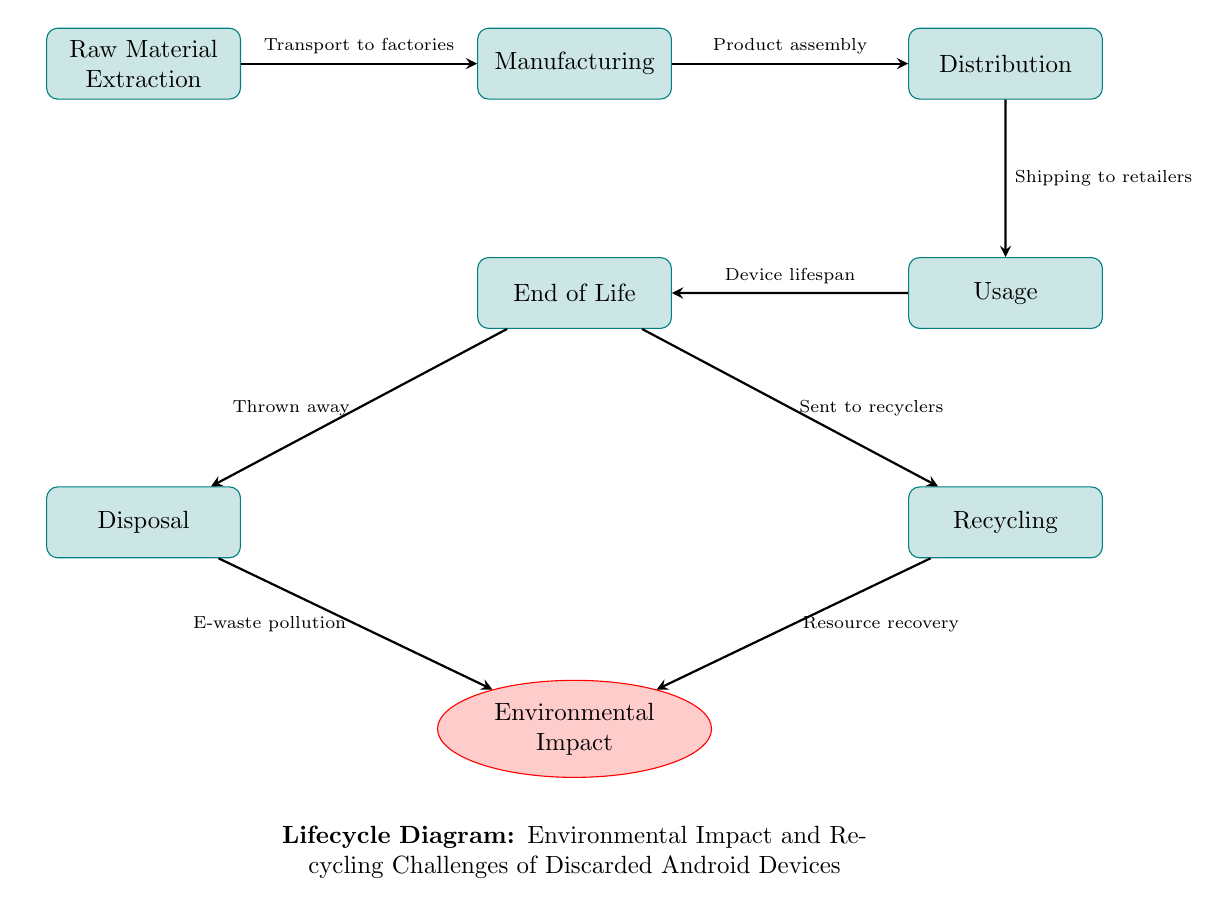What is the first step in the lifecycle of discarded Android devices? The first step in the lifecycle diagram is "Raw Material Extraction." It is the starting point before manufacturing.
Answer: Raw Material Extraction How many processes are depicted in the diagram? The diagram includes six processes: Raw Material Extraction, Manufacturing, Distribution, Usage, End of Life, Disposal, and Recycling. Counting these gives a total of six.
Answer: Six What happens during the 'End of Life' stage? During the 'End of Life' stage, devices can either be "Thrown away" or "Sent to recyclers." This stage represents the decisions made after the usage phase.
Answer: Thrown away or Sent to recyclers What impact does disposal have on the environment? The diagram indicates that disposal contributes to "E-waste pollution," which negatively impacts the environment as a direct consequence of disposing of discarded devices.
Answer: E-waste pollution What is the relationship between recycling and environmental impact? The diagram shows that recycling leads to "Resource recovery," which has a positive influence on the "Environmental Impact" by minimizing waste and reclaiming valuable materials.
Answer: Resource recovery What stage follows after 'Usage'? The stage that follows 'Usage' is the 'End of Life', where decisions are made regarding the future of the device after its usable lifespan has ended.
Answer: End of Life In which process is "Shipping to retailers" involved? "Shipping to retailers" is involved in the process of "Distribution," which comes after the manufacturing process and before usage.
Answer: Distribution What does the elliptical shape represent in this diagram? The elliptical shape in the diagram represents "Environmental Impact," highlighting its importance as a crucial factor affected by the lifecycle stages of discarded devices.
Answer: Environmental Impact What effect does "Resource recovery" have on environmental impact? "Resource recovery" contributes positively, as indicated in the diagram, which helps reduce negative environmental impacts by reclaiming valuable materials instead of contributing to waste.
Answer: Positive impact 